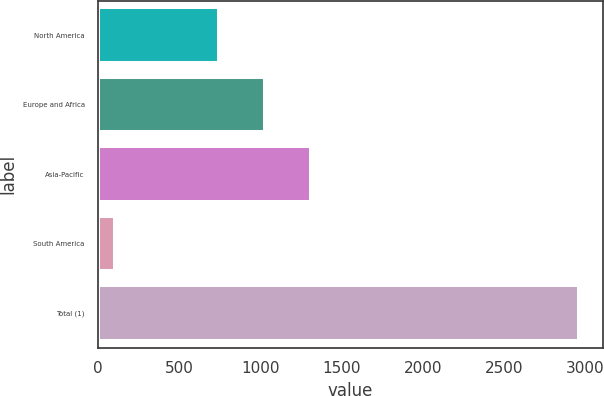Convert chart. <chart><loc_0><loc_0><loc_500><loc_500><bar_chart><fcel>North America<fcel>Europe and Africa<fcel>Asia-Pacific<fcel>South America<fcel>Total (1)<nl><fcel>743<fcel>1028.8<fcel>1314.6<fcel>103<fcel>2961<nl></chart> 